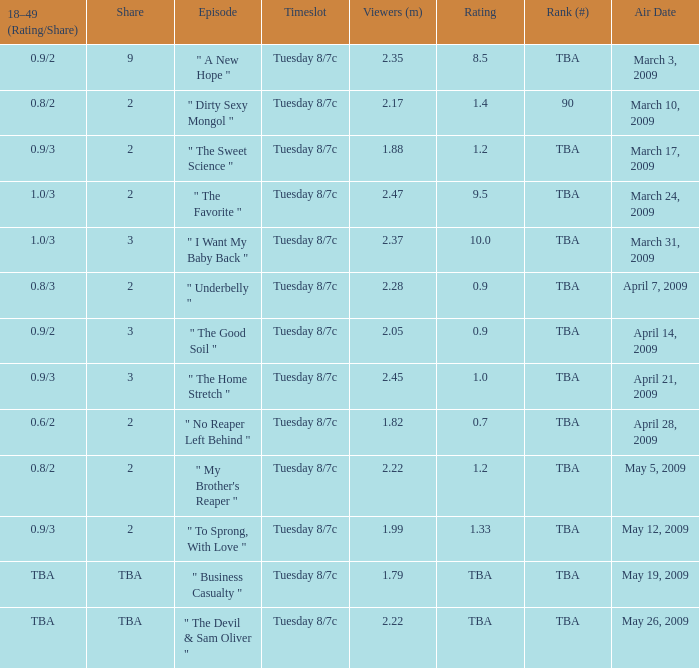On may 19, 2009, what was the ranking for the aired show? TBA. 